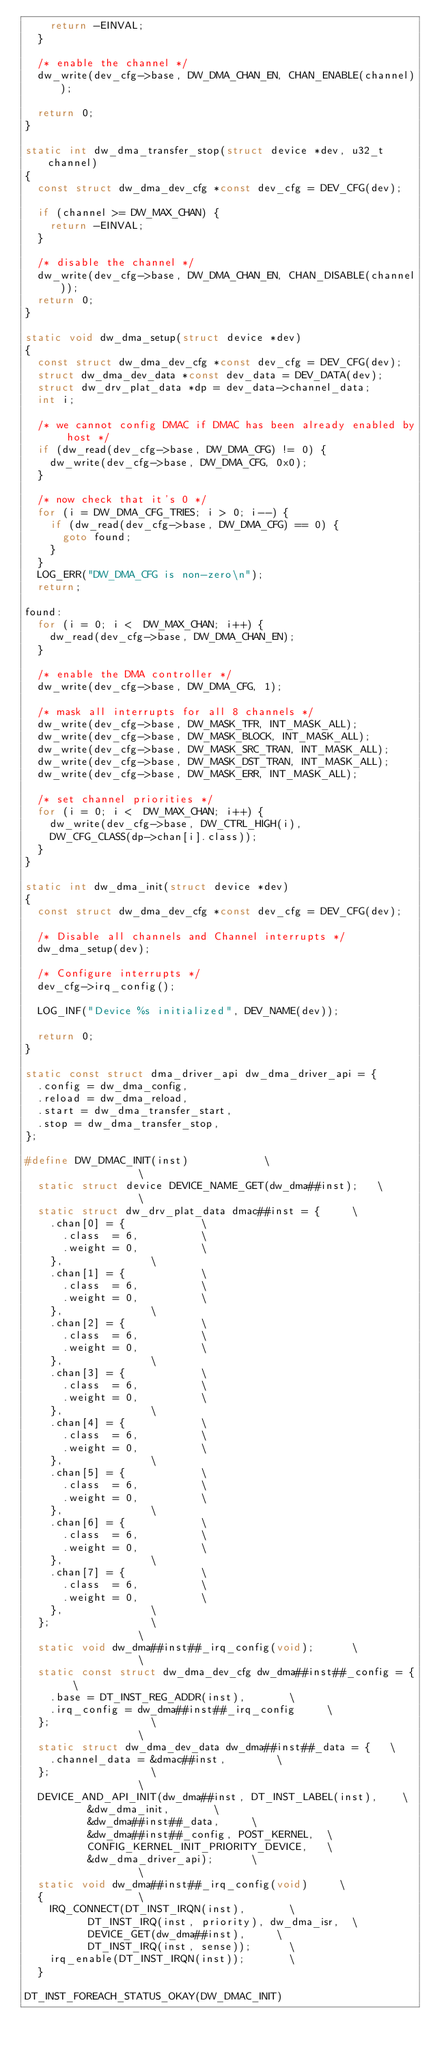<code> <loc_0><loc_0><loc_500><loc_500><_C_>		return -EINVAL;
	}

	/* enable the channel */
	dw_write(dev_cfg->base, DW_DMA_CHAN_EN, CHAN_ENABLE(channel));

	return 0;
}

static int dw_dma_transfer_stop(struct device *dev, u32_t channel)
{
	const struct dw_dma_dev_cfg *const dev_cfg = DEV_CFG(dev);

	if (channel >= DW_MAX_CHAN) {
		return -EINVAL;
	}

	/* disable the channel */
	dw_write(dev_cfg->base, DW_DMA_CHAN_EN, CHAN_DISABLE(channel));
	return 0;
}

static void dw_dma_setup(struct device *dev)
{
	const struct dw_dma_dev_cfg *const dev_cfg = DEV_CFG(dev);
	struct dw_dma_dev_data *const dev_data = DEV_DATA(dev);
	struct dw_drv_plat_data *dp = dev_data->channel_data;
	int i;

	/* we cannot config DMAC if DMAC has been already enabled by host */
	if (dw_read(dev_cfg->base, DW_DMA_CFG) != 0) {
		dw_write(dev_cfg->base, DW_DMA_CFG, 0x0);
	}

	/* now check that it's 0 */
	for (i = DW_DMA_CFG_TRIES; i > 0; i--) {
		if (dw_read(dev_cfg->base, DW_DMA_CFG) == 0) {
			goto found;
		}
	}
	LOG_ERR("DW_DMA_CFG is non-zero\n");
	return;

found:
	for (i = 0; i <  DW_MAX_CHAN; i++) {
		dw_read(dev_cfg->base, DW_DMA_CHAN_EN);
	}

	/* enable the DMA controller */
	dw_write(dev_cfg->base, DW_DMA_CFG, 1);

	/* mask all interrupts for all 8 channels */
	dw_write(dev_cfg->base, DW_MASK_TFR, INT_MASK_ALL);
	dw_write(dev_cfg->base, DW_MASK_BLOCK, INT_MASK_ALL);
	dw_write(dev_cfg->base, DW_MASK_SRC_TRAN, INT_MASK_ALL);
	dw_write(dev_cfg->base, DW_MASK_DST_TRAN, INT_MASK_ALL);
	dw_write(dev_cfg->base, DW_MASK_ERR, INT_MASK_ALL);

	/* set channel priorities */
	for (i = 0; i <  DW_MAX_CHAN; i++) {
		dw_write(dev_cfg->base, DW_CTRL_HIGH(i),
		DW_CFG_CLASS(dp->chan[i].class));
	}
}

static int dw_dma_init(struct device *dev)
{
	const struct dw_dma_dev_cfg *const dev_cfg = DEV_CFG(dev);

	/* Disable all channels and Channel interrupts */
	dw_dma_setup(dev);

	/* Configure interrupts */
	dev_cfg->irq_config();

	LOG_INF("Device %s initialized", DEV_NAME(dev));

	return 0;
}

static const struct dma_driver_api dw_dma_driver_api = {
	.config = dw_dma_config,
	.reload = dw_dma_reload,
	.start = dw_dma_transfer_start,
	.stop = dw_dma_transfer_stop,
};

#define DW_DMAC_INIT(inst)						\
									\
	static struct device DEVICE_NAME_GET(dw_dma##inst);		\
									\
	static struct dw_drv_plat_data dmac##inst = {			\
		.chan[0] = {						\
			.class  = 6,					\
			.weight = 0,					\
		},							\
		.chan[1] = {						\
			.class  = 6,					\
			.weight = 0,					\
		},							\
		.chan[2] = {						\
			.class  = 6,					\
			.weight = 0,					\
		},							\
		.chan[3] = {						\
			.class  = 6,					\
			.weight = 0,					\
		},							\
		.chan[4] = {						\
			.class  = 6,					\
			.weight = 0,					\
		},							\
		.chan[5] = {						\
			.class  = 6,					\
			.weight = 0,					\
		},							\
		.chan[6] = {						\
			.class  = 6,					\
			.weight = 0,					\
		},							\
		.chan[7] = {						\
			.class  = 6,					\
			.weight = 0,					\
		},							\
	};								\
									\
	static void dw_dma##inst##_irq_config(void);			\
									\
	static const struct dw_dma_dev_cfg dw_dma##inst##_config = {	\
		.base = DT_INST_REG_ADDR(inst),				\
		.irq_config = dw_dma##inst##_irq_config			\
	};								\
									\
	static struct dw_dma_dev_data dw_dma##inst##_data = {		\
		.channel_data = &dmac##inst,				\
	};								\
									\
	DEVICE_AND_API_INIT(dw_dma##inst, DT_INST_LABEL(inst),		\
			    &dw_dma_init,				\
			    &dw_dma##inst##_data,			\
			    &dw_dma##inst##_config, POST_KERNEL,	\
			    CONFIG_KERNEL_INIT_PRIORITY_DEVICE,		\
			    &dw_dma_driver_api);			\
									\
	static void dw_dma##inst##_irq_config(void)			\
	{								\
		IRQ_CONNECT(DT_INST_IRQN(inst),				\
			    DT_INST_IRQ(inst, priority), dw_dma_isr,	\
			    DEVICE_GET(dw_dma##inst),			\
			    DT_INST_IRQ(inst, sense));			\
		irq_enable(DT_INST_IRQN(inst));				\
	}

DT_INST_FOREACH_STATUS_OKAY(DW_DMAC_INIT)
</code> 